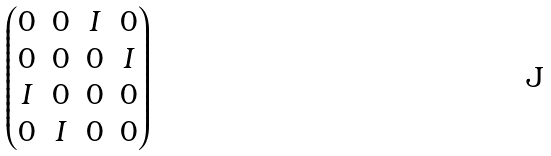Convert formula to latex. <formula><loc_0><loc_0><loc_500><loc_500>\begin{pmatrix} 0 & 0 & I & 0 \\ 0 & 0 & 0 & I \\ I & 0 & 0 & 0 \\ 0 & I & 0 & 0 \end{pmatrix}</formula> 